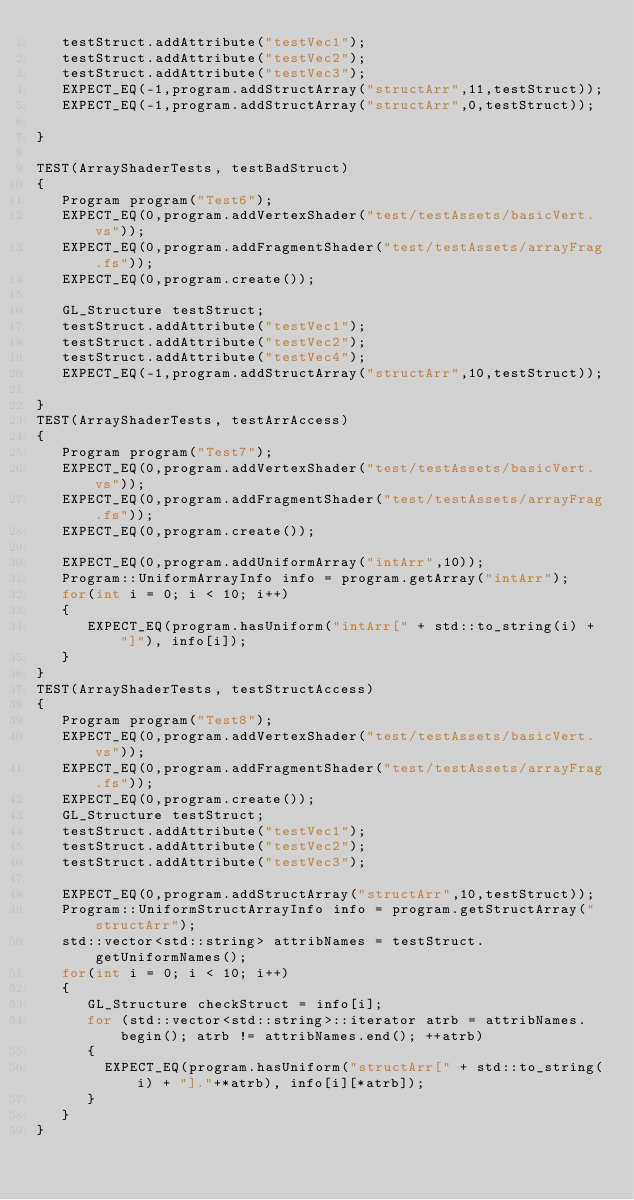Convert code to text. <code><loc_0><loc_0><loc_500><loc_500><_C++_>   testStruct.addAttribute("testVec1");
   testStruct.addAttribute("testVec2");
   testStruct.addAttribute("testVec3");
   EXPECT_EQ(-1,program.addStructArray("structArr",11,testStruct));
   EXPECT_EQ(-1,program.addStructArray("structArr",0,testStruct));

}

TEST(ArrayShaderTests, testBadStruct)
{
   Program program("Test6");
   EXPECT_EQ(0,program.addVertexShader("test/testAssets/basicVert.vs"));
   EXPECT_EQ(0,program.addFragmentShader("test/testAssets/arrayFrag.fs"));
   EXPECT_EQ(0,program.create());

   GL_Structure testStruct;
   testStruct.addAttribute("testVec1");
   testStruct.addAttribute("testVec2");
   testStruct.addAttribute("testVec4");
   EXPECT_EQ(-1,program.addStructArray("structArr",10,testStruct));

}
TEST(ArrayShaderTests, testArrAccess)
{
   Program program("Test7");
   EXPECT_EQ(0,program.addVertexShader("test/testAssets/basicVert.vs"));
   EXPECT_EQ(0,program.addFragmentShader("test/testAssets/arrayFrag.fs"));
   EXPECT_EQ(0,program.create());

   EXPECT_EQ(0,program.addUniformArray("intArr",10));
   Program::UniformArrayInfo info = program.getArray("intArr");
   for(int i = 0; i < 10; i++)
   {
      EXPECT_EQ(program.hasUniform("intArr[" + std::to_string(i) + "]"), info[i]);
   }
}
TEST(ArrayShaderTests, testStructAccess)
{
   Program program("Test8");
   EXPECT_EQ(0,program.addVertexShader("test/testAssets/basicVert.vs"));
   EXPECT_EQ(0,program.addFragmentShader("test/testAssets/arrayFrag.fs"));
   EXPECT_EQ(0,program.create());
   GL_Structure testStruct;
   testStruct.addAttribute("testVec1");
   testStruct.addAttribute("testVec2");
   testStruct.addAttribute("testVec3");

   EXPECT_EQ(0,program.addStructArray("structArr",10,testStruct));
   Program::UniformStructArrayInfo info = program.getStructArray("structArr");
   std::vector<std::string> attribNames = testStruct.getUniformNames();
   for(int i = 0; i < 10; i++)
   {
      GL_Structure checkStruct = info[i];
      for (std::vector<std::string>::iterator atrb = attribNames.begin(); atrb != attribNames.end(); ++atrb)
      {
        EXPECT_EQ(program.hasUniform("structArr[" + std::to_string(i) + "]."+*atrb), info[i][*atrb]);
      }
   }
}</code> 